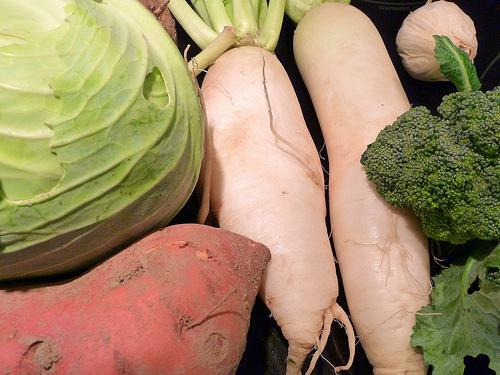Question: what is in the picture?
Choices:
A. Fruits.
B. Foods.
C. Table.
D. Vegetables.
Answer with the letter. Answer: D Question: what is the light green vegetable?
Choices:
A. Lettuce.
B. Kale.
C. Cabbage.
D. Cucumber.
Answer with the letter. Answer: C Question: what is the dark green vegetable?
Choices:
A. Green pepper.
B. Cucumber.
C. Kale.
D. Broccoli.
Answer with the letter. Answer: D Question: how many cabbages are there?
Choices:
A. 3.
B. 2.
C. 4.
D. 1.
Answer with the letter. Answer: D Question: what color is the potato?
Choices:
A. Red.
B. Brown.
C. Purple.
D. Yellow.
Answer with the letter. Answer: A Question: where does the potato grow?
Choices:
A. The garden.
B. Ground.
C. A planter box.
D. Farm.
Answer with the letter. Answer: B 